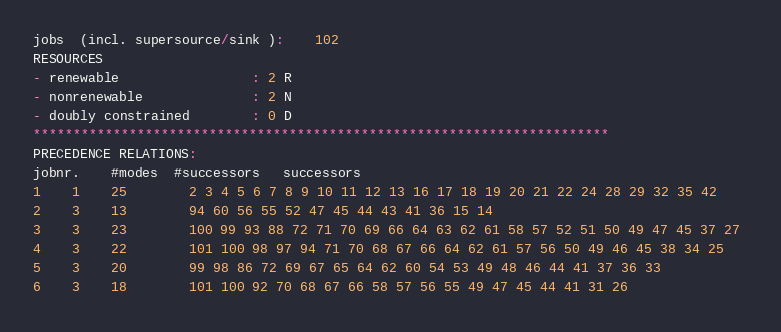Convert code to text. <code><loc_0><loc_0><loc_500><loc_500><_ObjectiveC_>jobs  (incl. supersource/sink ):	102
RESOURCES
- renewable                 : 2 R
- nonrenewable              : 2 N
- doubly constrained        : 0 D
************************************************************************
PRECEDENCE RELATIONS:
jobnr.    #modes  #successors   successors
1	1	25		2 3 4 5 6 7 8 9 10 11 12 13 16 17 18 19 20 21 22 24 28 29 32 35 42 
2	3	13		94 60 56 55 52 47 45 44 43 41 36 15 14 
3	3	23		100 99 93 88 72 71 70 69 66 64 63 62 61 58 57 52 51 50 49 47 45 37 27 
4	3	22		101 100 98 97 94 71 70 68 67 66 64 62 61 57 56 50 49 46 45 38 34 25 
5	3	20		99 98 86 72 69 67 65 64 62 60 54 53 49 48 46 44 41 37 36 33 
6	3	18		101 100 92 70 68 67 66 58 57 56 55 49 47 45 44 41 31 26 </code> 